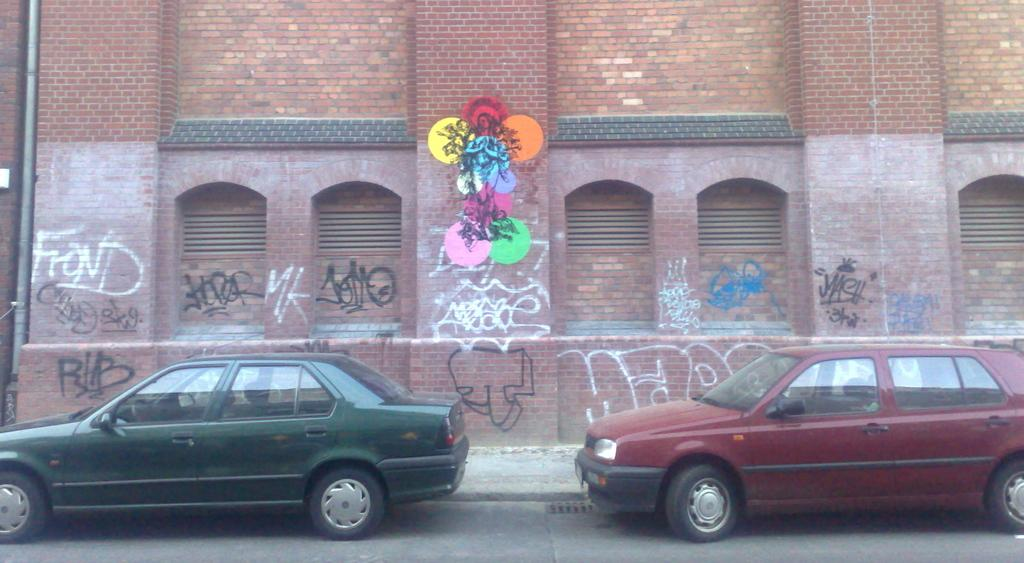What type of structure is visible in the image? There is a building in the image. What feature can be seen on the building? The building has windows. What other object is present in the image? There is a pipe in the image. What is written or displayed on the building? There is text on the wall of the building. What type of vehicles can be seen on the ground in the image? There are cars on the ground in the image. What type of pet does the grandfather have in the image? There is no grandfather or pet present in the image. What kind of marble is used to decorate the building in the image? There is no marble visible in the image; the building has text on its wall instead. 